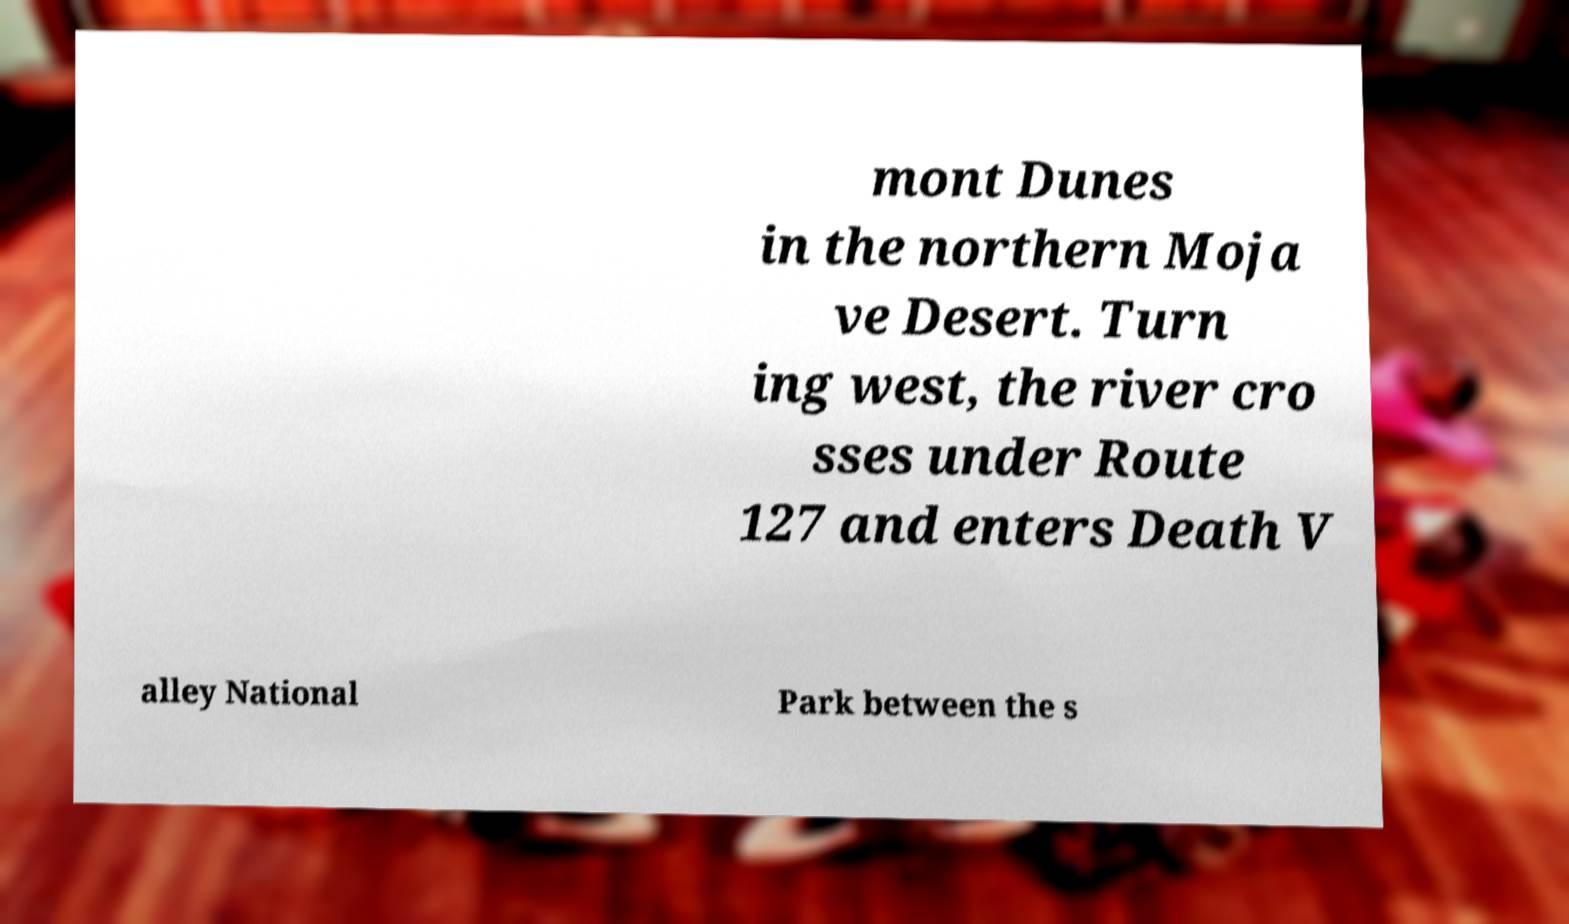Could you assist in decoding the text presented in this image and type it out clearly? mont Dunes in the northern Moja ve Desert. Turn ing west, the river cro sses under Route 127 and enters Death V alley National Park between the s 